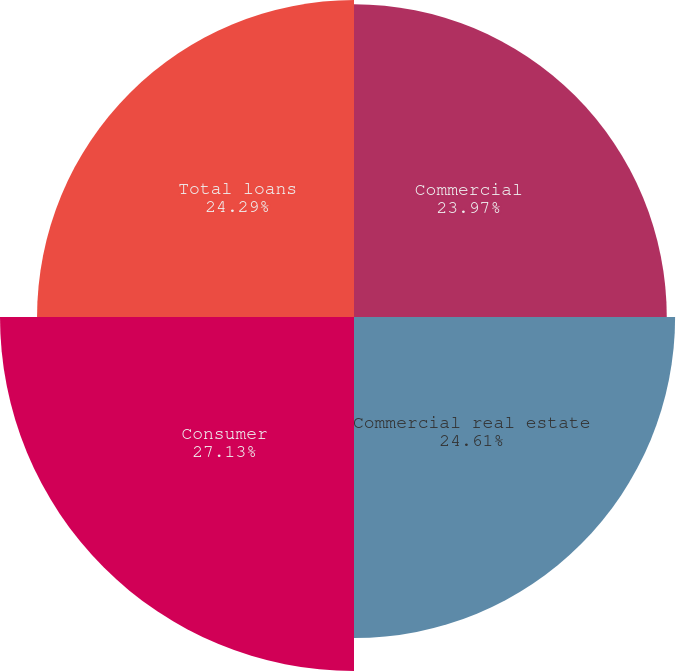Convert chart to OTSL. <chart><loc_0><loc_0><loc_500><loc_500><pie_chart><fcel>Commercial<fcel>Commercial real estate<fcel>Consumer<fcel>Total loans<nl><fcel>23.97%<fcel>24.61%<fcel>27.13%<fcel>24.29%<nl></chart> 